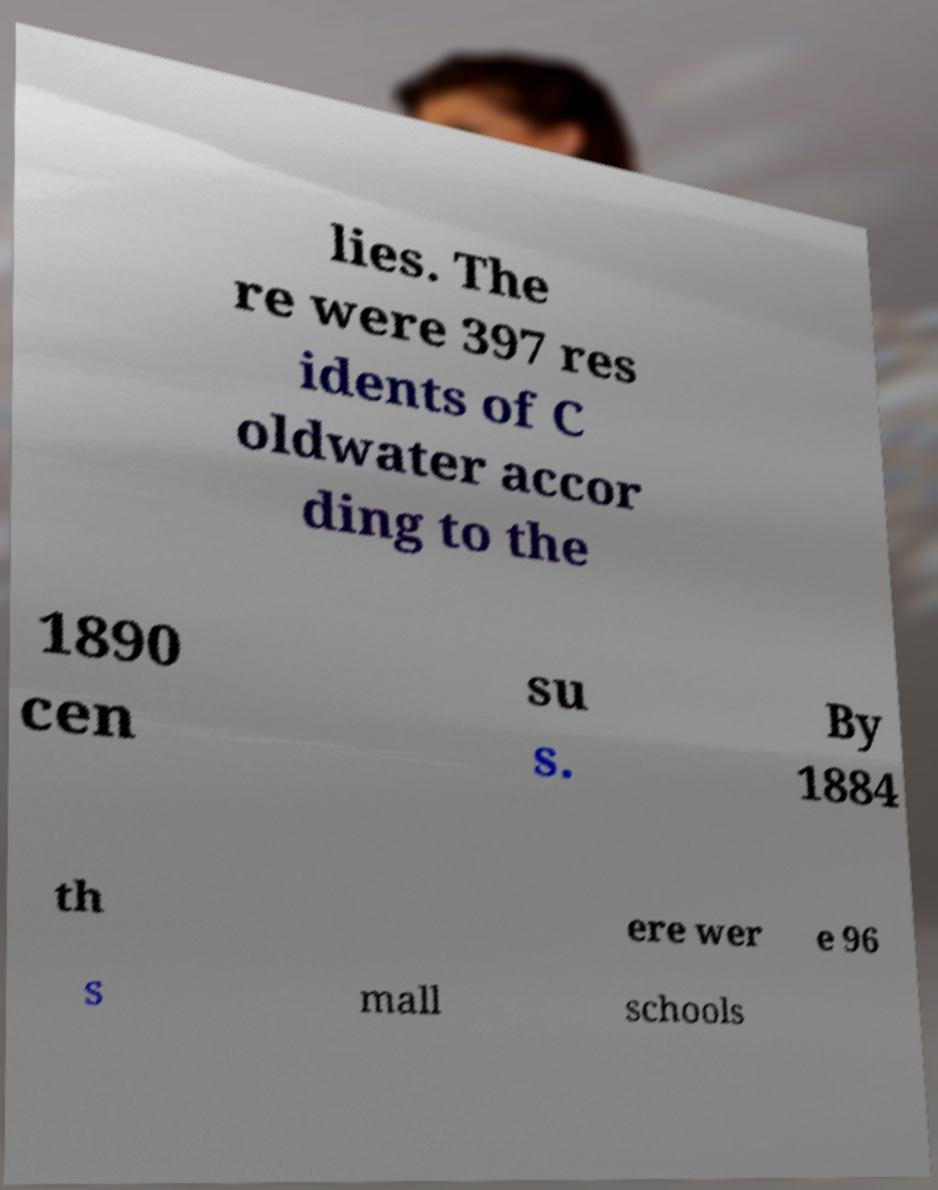I need the written content from this picture converted into text. Can you do that? lies. The re were 397 res idents of C oldwater accor ding to the 1890 cen su s. By 1884 th ere wer e 96 s mall schools 